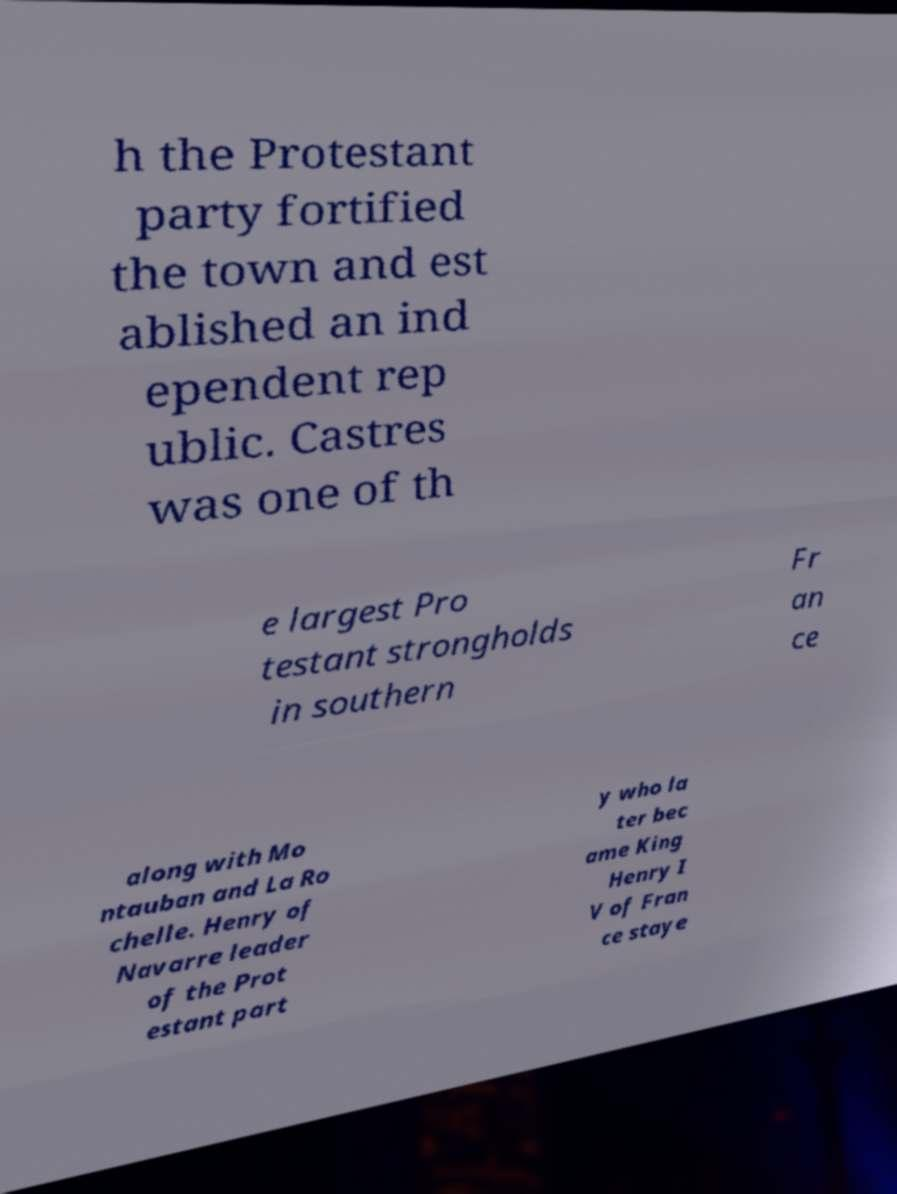Can you read and provide the text displayed in the image?This photo seems to have some interesting text. Can you extract and type it out for me? h the Protestant party fortified the town and est ablished an ind ependent rep ublic. Castres was one of th e largest Pro testant strongholds in southern Fr an ce along with Mo ntauban and La Ro chelle. Henry of Navarre leader of the Prot estant part y who la ter bec ame King Henry I V of Fran ce staye 